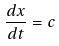Convert formula to latex. <formula><loc_0><loc_0><loc_500><loc_500>\frac { d x } { d t } = c</formula> 